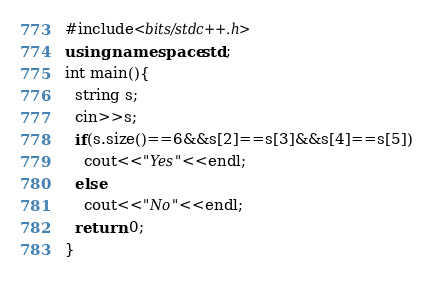<code> <loc_0><loc_0><loc_500><loc_500><_C++_>#include<bits/stdc++.h>
using namespace std;
int main(){
  string s;
  cin>>s;
  if(s.size()==6&&s[2]==s[3]&&s[4]==s[5])
    cout<<"Yes"<<endl;
  else
    cout<<"No"<<endl;
  return 0;
}</code> 